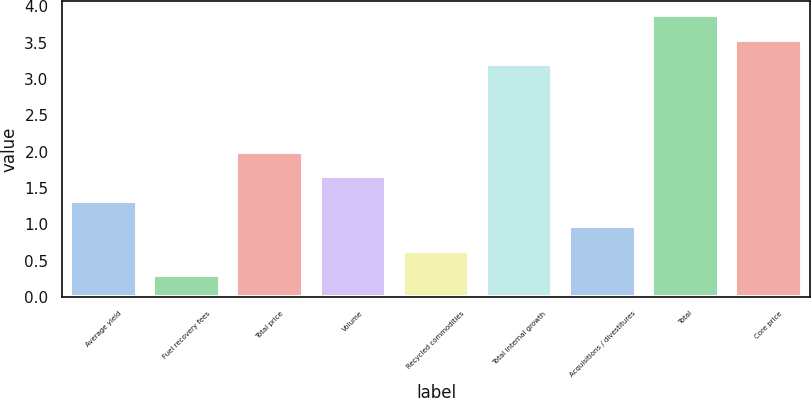<chart> <loc_0><loc_0><loc_500><loc_500><bar_chart><fcel>Average yield<fcel>Fuel recovery fees<fcel>Total price<fcel>Volume<fcel>Recycled commodities<fcel>Total internal growth<fcel>Acquisitions / divestitures<fcel>Total<fcel>Core price<nl><fcel>1.32<fcel>0.3<fcel>2<fcel>1.66<fcel>0.64<fcel>3.2<fcel>0.98<fcel>3.88<fcel>3.54<nl></chart> 